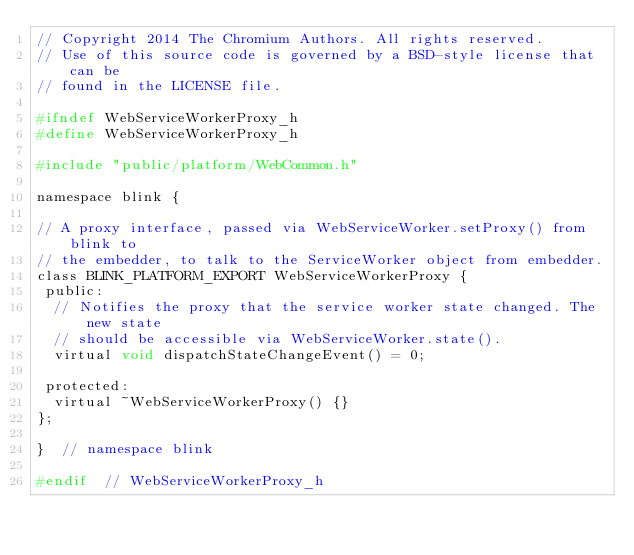Convert code to text. <code><loc_0><loc_0><loc_500><loc_500><_C_>// Copyright 2014 The Chromium Authors. All rights reserved.
// Use of this source code is governed by a BSD-style license that can be
// found in the LICENSE file.

#ifndef WebServiceWorkerProxy_h
#define WebServiceWorkerProxy_h

#include "public/platform/WebCommon.h"

namespace blink {

// A proxy interface, passed via WebServiceWorker.setProxy() from blink to
// the embedder, to talk to the ServiceWorker object from embedder.
class BLINK_PLATFORM_EXPORT WebServiceWorkerProxy {
 public:
  // Notifies the proxy that the service worker state changed. The new state
  // should be accessible via WebServiceWorker.state().
  virtual void dispatchStateChangeEvent() = 0;

 protected:
  virtual ~WebServiceWorkerProxy() {}
};

}  // namespace blink

#endif  // WebServiceWorkerProxy_h
</code> 